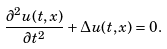<formula> <loc_0><loc_0><loc_500><loc_500>\frac { \partial ^ { 2 } u ( t , x ) } { \partial t ^ { 2 } } + \Delta u ( t , x ) = 0 .</formula> 